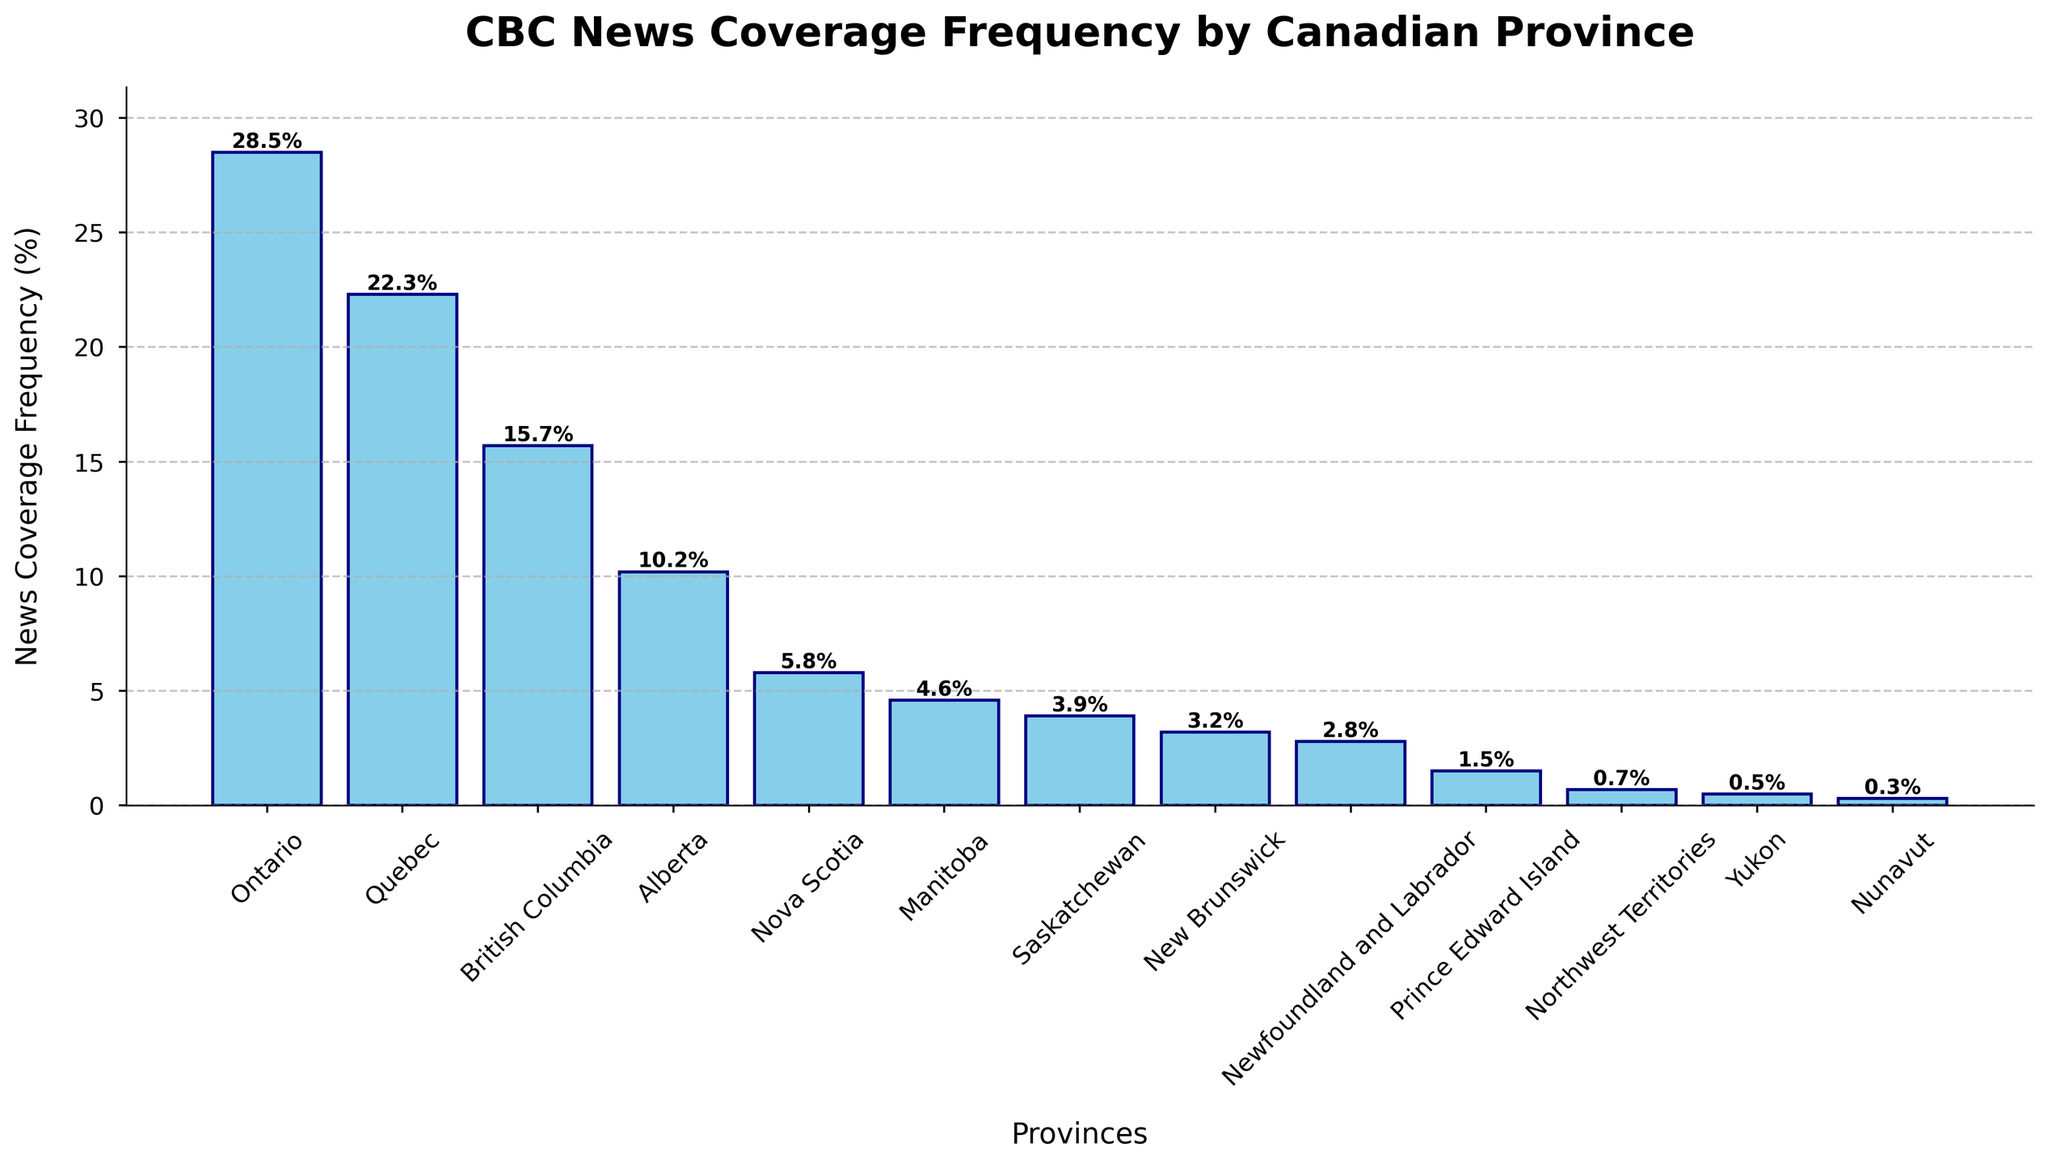Which province has the highest news coverage frequency? Ontario has the highest bar in the chart, indicating it has the highest news coverage frequency at 28.5%.
Answer: Ontario Which province has the lowest news coverage frequency? Nunavut has the shortest bar in the chart, indicating it has the lowest news coverage frequency at 0.3%.
Answer: Nunavut What is the difference in news coverage frequency between Ontario and British Columbia? The height of Ontario's bar is 28.5% and the height of British Columbia's bar is 15.7%. The difference is calculated as 28.5% - 15.7%.
Answer: 12.8% Which provinces have a news coverage frequency above 20%? By examining the bar heights, only Ontario (28.5%) and Quebec (22.3%) have bars that extend above the 20% mark.
Answer: Ontario and Quebec What is the total news coverage frequency for the Prairie provinces (Alberta, Saskatchewan, and Manitoba)? Summing the heights of the bars for Alberta (10.2%), Saskatchewan (3.9%), and Manitoba (4.6%) gives a total of 10.2% + 3.9% + 4.6%.
Answer: 18.7% Which province has a news coverage frequency closest to 5%? Nova Scotia's bar is closest to 5% with a frequency of 5.8%.
Answer: Nova Scotia How many provinces have a news coverage frequency less than 5%? Counting the number of bars with heights below the 5% mark, the provinces are Manitoba (4.6%), Saskatchewan (3.9%), New Brunswick (3.2%), Newfoundland and Labrador (2.8%), Prince Edward Island (1.5%), Northwest Territories (0.7%), Yukon (0.5%), and Nunavut (0.3%), making a total of 8.
Answer: 8 What is the average news coverage frequency for the Atlantic provinces (Nova Scotia, New Brunswick, Newfoundland and Labrador, and Prince Edward Island)? Summing the frequencies of Nova Scotia (5.8%), New Brunswick (3.2%), Newfoundland and Labrador (2.8%), and Prince Edward Island (1.5%), we get 5.8% + 3.2% + 2.8% + 1.5% = 13.3%. Dividing by 4 (the number of provinces) gives 13.3% / 4.
Answer: 3.325% Which province has a news coverage frequency closest to the median value? The median is the middle value in the sorted list. After sorting the frequencies, the median is the average of the 7th and 8th values (3.9% for Saskatchewan and 3.2% for New Brunswick), giving (3.9 + 3.2) / 2 = 3.55%. The closest province to this value is Saskatchewan with 3.9%.
Answer: Saskatchewan Which two provinces combined have a news coverage frequency higher than Ontario? Checking various combinations, Alberta (10.2%) and Quebec (22.3%) together have a combined frequency of 10.2% + 22.3% = 32.5%, which is higher than Ontario's 28.5%.
Answer: Alberta and Quebec 